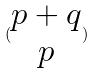Convert formula to latex. <formula><loc_0><loc_0><loc_500><loc_500>( \begin{matrix} p + q \\ p \end{matrix} )</formula> 